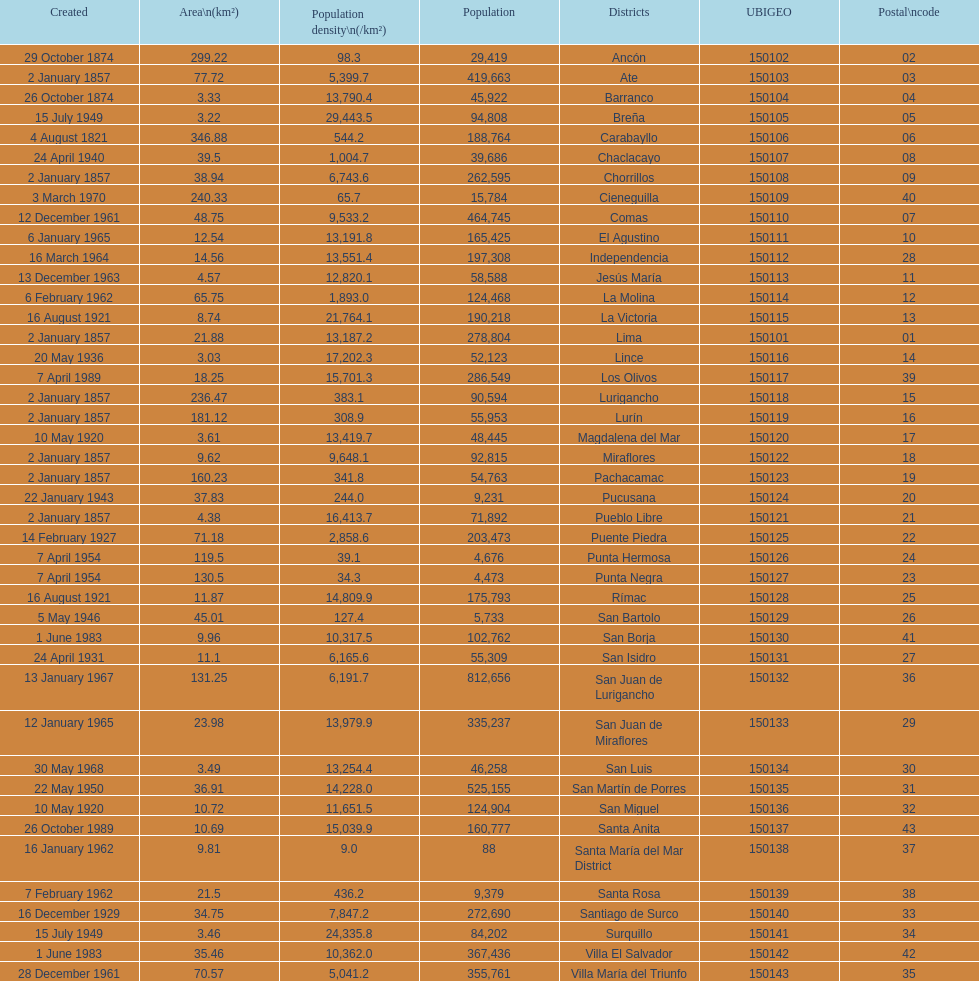What district has the least amount of population? Santa María del Mar District. 